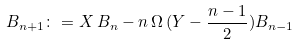Convert formula to latex. <formula><loc_0><loc_0><loc_500><loc_500>B _ { n + 1 } \colon = X \, B _ { n } - n \, \Omega \, ( Y - \frac { n - 1 } { 2 } ) B _ { n - 1 }</formula> 